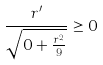<formula> <loc_0><loc_0><loc_500><loc_500>\frac { r ^ { \prime } } { \sqrt { 0 + \frac { r ^ { 2 } } { 9 } } } \geq 0</formula> 